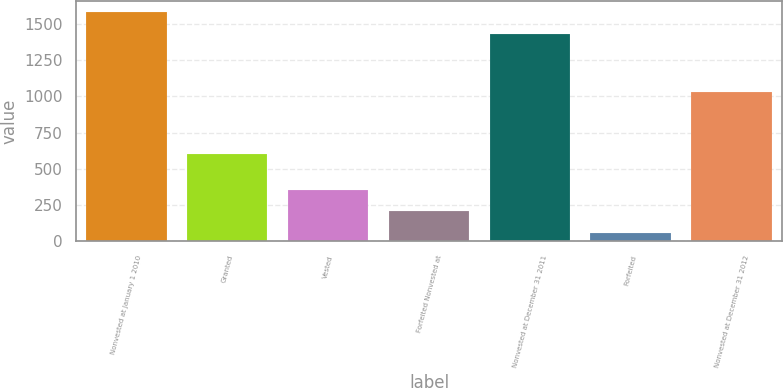Convert chart. <chart><loc_0><loc_0><loc_500><loc_500><bar_chart><fcel>Nonvested at January 1 2010<fcel>Granted<fcel>Vested<fcel>Forfeited Nonvested at<fcel>Nonvested at December 31 2011<fcel>Forfeited<fcel>Nonvested at December 31 2012<nl><fcel>1578.6<fcel>603<fcel>358.2<fcel>209.6<fcel>1430<fcel>61<fcel>1032<nl></chart> 